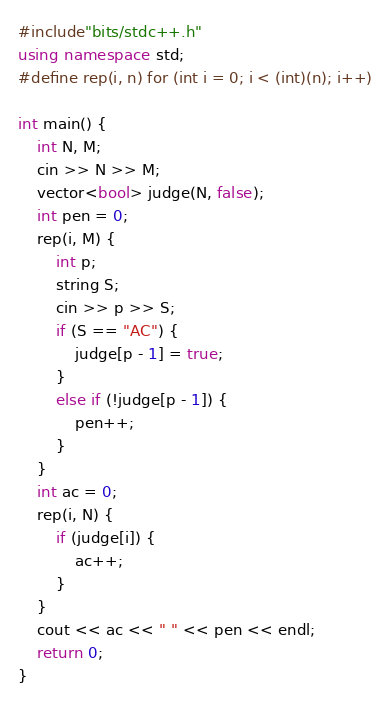Convert code to text. <code><loc_0><loc_0><loc_500><loc_500><_C++_>#include"bits/stdc++.h"
using namespace std;
#define rep(i, n) for (int i = 0; i < (int)(n); i++)

int main() {
	int N, M;
	cin >> N >> M;
	vector<bool> judge(N, false);
	int pen = 0;
	rep(i, M) {
		int p;
		string S;
		cin >> p >> S;
		if (S == "AC") {
			judge[p - 1] = true;
		}
		else if (!judge[p - 1]) {
			pen++;
		}
	}
	int ac = 0;
	rep(i, N) {
		if (judge[i]) {
			ac++;
		}
	}
	cout << ac << " " << pen << endl;
	return 0;
}</code> 